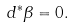Convert formula to latex. <formula><loc_0><loc_0><loc_500><loc_500>d ^ { * } \beta = 0 .</formula> 